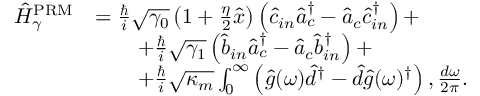<formula> <loc_0><loc_0><loc_500><loc_500>\begin{array} { r l } { \hat { H } _ { \gamma } ^ { P R M } } & { = \frac { \hslash } { i } \sqrt { \gamma _ { 0 } } \left ( 1 + \frac { \eta } { 2 } \hat { x } \right ) \left ( \hat { c } _ { i n } \hat { a } _ { c } ^ { \dagger } - \hat { a } _ { c } \hat { c } _ { i n } ^ { \dag } \right ) + } \\ & { \quad + \frac { \hslash } { i } \sqrt { \gamma _ { 1 } } \left ( \hat { b } _ { i n } \hat { a } _ { c } ^ { \dagger } - \hat { a } _ { c } \hat { b } _ { i n } ^ { \dag } \right ) + } \\ & { \quad + \frac { \hslash } { i } \sqrt { \kappa _ { m } } \int _ { 0 } ^ { \infty } \left ( \hat { g } ( \omega ) \hat { d } ^ { \dagger } - \hat { d } \hat { g } ( \omega ) ^ { \dag } \right ) , \frac { d \omega } { 2 \pi } . } \end{array}</formula> 